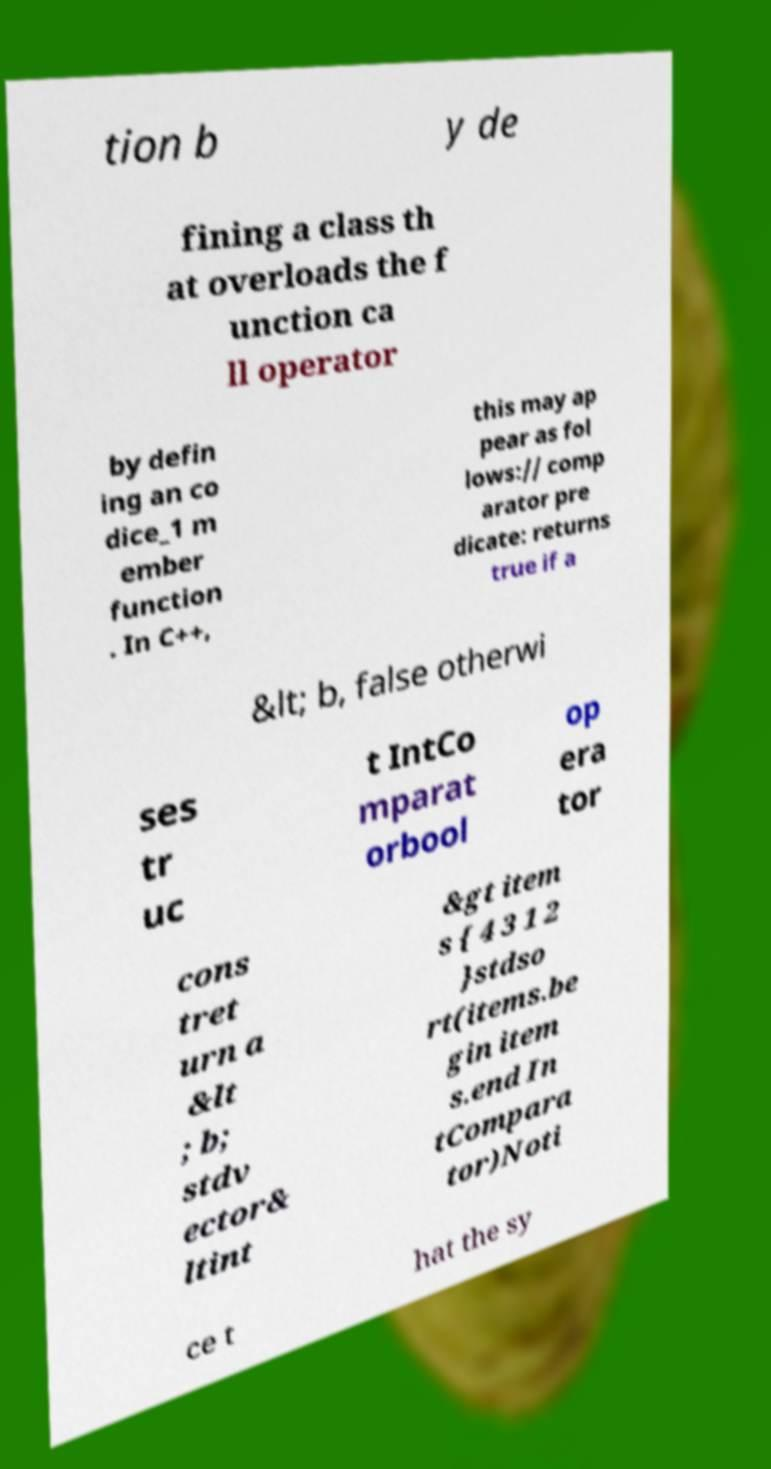Could you assist in decoding the text presented in this image and type it out clearly? tion b y de fining a class th at overloads the f unction ca ll operator by defin ing an co dice_1 m ember function . In C++, this may ap pear as fol lows:// comp arator pre dicate: returns true if a &lt; b, false otherwi ses tr uc t IntCo mparat orbool op era tor cons tret urn a &lt ; b; stdv ector& ltint &gt item s { 4 3 1 2 }stdso rt(items.be gin item s.end In tCompara tor)Noti ce t hat the sy 